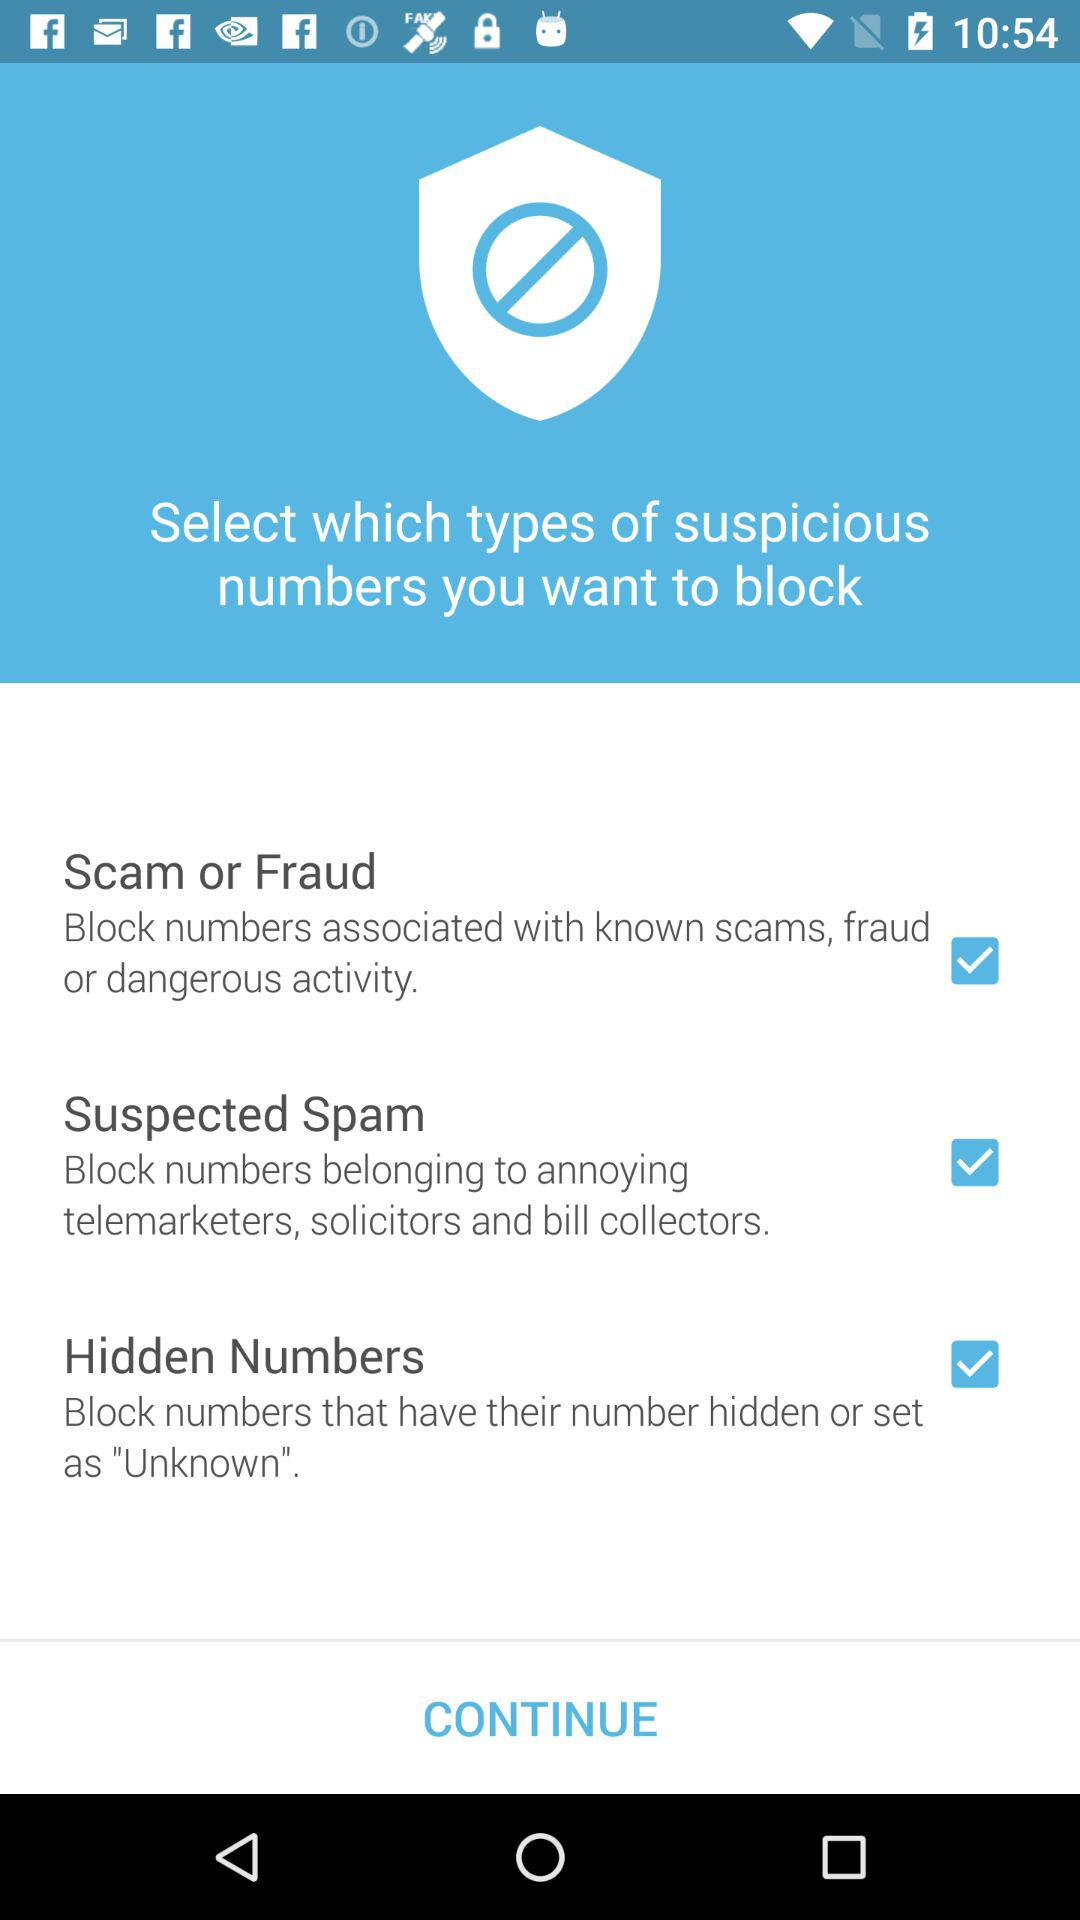What is the status of the "Hidden Numbers"? The status of the "Hidden Numbers" is "on". 